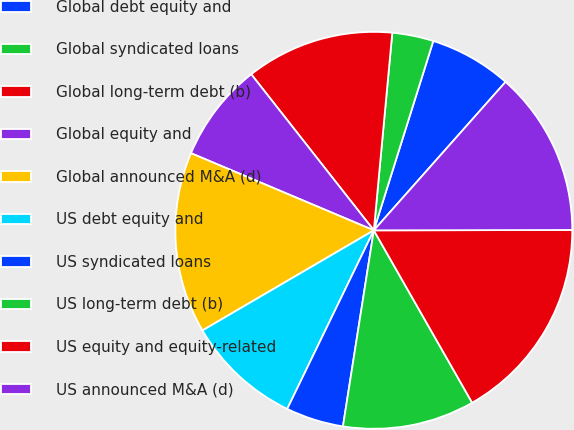Convert chart. <chart><loc_0><loc_0><loc_500><loc_500><pie_chart><fcel>Global debt equity and<fcel>Global syndicated loans<fcel>Global long-term debt (b)<fcel>Global equity and<fcel>Global announced M&A (d)<fcel>US debt equity and<fcel>US syndicated loans<fcel>US long-term debt (b)<fcel>US equity and equity-related<fcel>US announced M&A (d)<nl><fcel>6.71%<fcel>3.36%<fcel>12.08%<fcel>8.05%<fcel>14.77%<fcel>9.4%<fcel>4.7%<fcel>10.74%<fcel>16.78%<fcel>13.42%<nl></chart> 